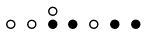Convert formula to latex. <formula><loc_0><loc_0><loc_500><loc_500>\begin{smallmatrix} & & \circ \\ \circ & \circ & \bullet & \bullet & \circ & \bullet & \bullet & \\ \end{smallmatrix}</formula> 